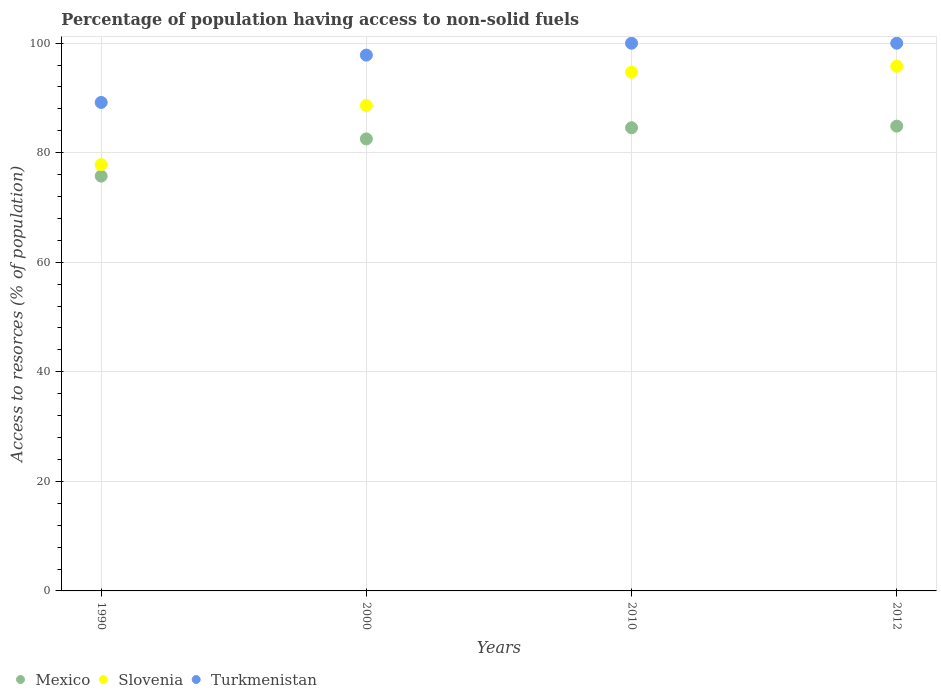How many different coloured dotlines are there?
Provide a short and direct response. 3. Is the number of dotlines equal to the number of legend labels?
Offer a terse response. Yes. What is the percentage of population having access to non-solid fuels in Turkmenistan in 2010?
Ensure brevity in your answer.  99.99. Across all years, what is the maximum percentage of population having access to non-solid fuels in Turkmenistan?
Offer a very short reply. 99.99. Across all years, what is the minimum percentage of population having access to non-solid fuels in Slovenia?
Ensure brevity in your answer.  77.82. In which year was the percentage of population having access to non-solid fuels in Mexico maximum?
Your response must be concise. 2012. In which year was the percentage of population having access to non-solid fuels in Turkmenistan minimum?
Keep it short and to the point. 1990. What is the total percentage of population having access to non-solid fuels in Slovenia in the graph?
Provide a succinct answer. 356.93. What is the difference between the percentage of population having access to non-solid fuels in Slovenia in 2000 and that in 2012?
Your answer should be very brief. -7.17. What is the difference between the percentage of population having access to non-solid fuels in Mexico in 2000 and the percentage of population having access to non-solid fuels in Turkmenistan in 1990?
Make the answer very short. -6.66. What is the average percentage of population having access to non-solid fuels in Slovenia per year?
Your answer should be very brief. 89.23. In the year 2012, what is the difference between the percentage of population having access to non-solid fuels in Turkmenistan and percentage of population having access to non-solid fuels in Mexico?
Your response must be concise. 15.14. In how many years, is the percentage of population having access to non-solid fuels in Turkmenistan greater than 72 %?
Offer a terse response. 4. What is the ratio of the percentage of population having access to non-solid fuels in Slovenia in 2000 to that in 2010?
Your response must be concise. 0.94. Is the difference between the percentage of population having access to non-solid fuels in Turkmenistan in 2000 and 2010 greater than the difference between the percentage of population having access to non-solid fuels in Mexico in 2000 and 2010?
Give a very brief answer. No. What is the difference between the highest and the second highest percentage of population having access to non-solid fuels in Slovenia?
Provide a succinct answer. 1.11. What is the difference between the highest and the lowest percentage of population having access to non-solid fuels in Slovenia?
Provide a succinct answer. 17.97. Is the sum of the percentage of population having access to non-solid fuels in Mexico in 1990 and 2012 greater than the maximum percentage of population having access to non-solid fuels in Slovenia across all years?
Ensure brevity in your answer.  Yes. Is it the case that in every year, the sum of the percentage of population having access to non-solid fuels in Mexico and percentage of population having access to non-solid fuels in Slovenia  is greater than the percentage of population having access to non-solid fuels in Turkmenistan?
Make the answer very short. Yes. Is the percentage of population having access to non-solid fuels in Mexico strictly greater than the percentage of population having access to non-solid fuels in Slovenia over the years?
Ensure brevity in your answer.  No. Is the percentage of population having access to non-solid fuels in Mexico strictly less than the percentage of population having access to non-solid fuels in Slovenia over the years?
Your answer should be very brief. Yes. How many dotlines are there?
Give a very brief answer. 3. What is the difference between two consecutive major ticks on the Y-axis?
Offer a very short reply. 20. Are the values on the major ticks of Y-axis written in scientific E-notation?
Your answer should be very brief. No. Does the graph contain grids?
Provide a succinct answer. Yes. How are the legend labels stacked?
Offer a terse response. Horizontal. What is the title of the graph?
Keep it short and to the point. Percentage of population having access to non-solid fuels. What is the label or title of the Y-axis?
Provide a short and direct response. Access to resorces (% of population). What is the Access to resorces (% of population) in Mexico in 1990?
Give a very brief answer. 75.73. What is the Access to resorces (% of population) in Slovenia in 1990?
Your answer should be very brief. 77.82. What is the Access to resorces (% of population) of Turkmenistan in 1990?
Offer a terse response. 89.18. What is the Access to resorces (% of population) of Mexico in 2000?
Keep it short and to the point. 82.52. What is the Access to resorces (% of population) in Slovenia in 2000?
Give a very brief answer. 88.62. What is the Access to resorces (% of population) in Turkmenistan in 2000?
Your response must be concise. 97.82. What is the Access to resorces (% of population) of Mexico in 2010?
Ensure brevity in your answer.  84.56. What is the Access to resorces (% of population) of Slovenia in 2010?
Offer a very short reply. 94.69. What is the Access to resorces (% of population) of Turkmenistan in 2010?
Ensure brevity in your answer.  99.99. What is the Access to resorces (% of population) of Mexico in 2012?
Offer a terse response. 84.85. What is the Access to resorces (% of population) in Slovenia in 2012?
Give a very brief answer. 95.79. What is the Access to resorces (% of population) in Turkmenistan in 2012?
Your answer should be compact. 99.99. Across all years, what is the maximum Access to resorces (% of population) in Mexico?
Ensure brevity in your answer.  84.85. Across all years, what is the maximum Access to resorces (% of population) in Slovenia?
Make the answer very short. 95.79. Across all years, what is the maximum Access to resorces (% of population) of Turkmenistan?
Give a very brief answer. 99.99. Across all years, what is the minimum Access to resorces (% of population) in Mexico?
Provide a short and direct response. 75.73. Across all years, what is the minimum Access to resorces (% of population) of Slovenia?
Offer a terse response. 77.82. Across all years, what is the minimum Access to resorces (% of population) in Turkmenistan?
Offer a very short reply. 89.18. What is the total Access to resorces (% of population) in Mexico in the graph?
Keep it short and to the point. 327.66. What is the total Access to resorces (% of population) in Slovenia in the graph?
Offer a terse response. 356.93. What is the total Access to resorces (% of population) in Turkmenistan in the graph?
Offer a very short reply. 386.98. What is the difference between the Access to resorces (% of population) of Mexico in 1990 and that in 2000?
Offer a terse response. -6.79. What is the difference between the Access to resorces (% of population) in Slovenia in 1990 and that in 2000?
Offer a very short reply. -10.79. What is the difference between the Access to resorces (% of population) in Turkmenistan in 1990 and that in 2000?
Your answer should be very brief. -8.64. What is the difference between the Access to resorces (% of population) in Mexico in 1990 and that in 2010?
Your answer should be very brief. -8.83. What is the difference between the Access to resorces (% of population) in Slovenia in 1990 and that in 2010?
Offer a terse response. -16.86. What is the difference between the Access to resorces (% of population) of Turkmenistan in 1990 and that in 2010?
Offer a terse response. -10.81. What is the difference between the Access to resorces (% of population) in Mexico in 1990 and that in 2012?
Your answer should be compact. -9.12. What is the difference between the Access to resorces (% of population) of Slovenia in 1990 and that in 2012?
Provide a succinct answer. -17.97. What is the difference between the Access to resorces (% of population) in Turkmenistan in 1990 and that in 2012?
Make the answer very short. -10.81. What is the difference between the Access to resorces (% of population) of Mexico in 2000 and that in 2010?
Your response must be concise. -2.04. What is the difference between the Access to resorces (% of population) of Slovenia in 2000 and that in 2010?
Provide a short and direct response. -6.07. What is the difference between the Access to resorces (% of population) in Turkmenistan in 2000 and that in 2010?
Give a very brief answer. -2.17. What is the difference between the Access to resorces (% of population) in Mexico in 2000 and that in 2012?
Keep it short and to the point. -2.33. What is the difference between the Access to resorces (% of population) of Slovenia in 2000 and that in 2012?
Offer a very short reply. -7.17. What is the difference between the Access to resorces (% of population) of Turkmenistan in 2000 and that in 2012?
Your answer should be compact. -2.17. What is the difference between the Access to resorces (% of population) of Mexico in 2010 and that in 2012?
Keep it short and to the point. -0.29. What is the difference between the Access to resorces (% of population) in Slovenia in 2010 and that in 2012?
Your answer should be compact. -1.11. What is the difference between the Access to resorces (% of population) of Mexico in 1990 and the Access to resorces (% of population) of Slovenia in 2000?
Your answer should be compact. -12.89. What is the difference between the Access to resorces (% of population) in Mexico in 1990 and the Access to resorces (% of population) in Turkmenistan in 2000?
Give a very brief answer. -22.09. What is the difference between the Access to resorces (% of population) in Slovenia in 1990 and the Access to resorces (% of population) in Turkmenistan in 2000?
Your response must be concise. -20. What is the difference between the Access to resorces (% of population) in Mexico in 1990 and the Access to resorces (% of population) in Slovenia in 2010?
Offer a terse response. -18.96. What is the difference between the Access to resorces (% of population) of Mexico in 1990 and the Access to resorces (% of population) of Turkmenistan in 2010?
Offer a very short reply. -24.26. What is the difference between the Access to resorces (% of population) in Slovenia in 1990 and the Access to resorces (% of population) in Turkmenistan in 2010?
Offer a very short reply. -22.16. What is the difference between the Access to resorces (% of population) in Mexico in 1990 and the Access to resorces (% of population) in Slovenia in 2012?
Provide a short and direct response. -20.07. What is the difference between the Access to resorces (% of population) of Mexico in 1990 and the Access to resorces (% of population) of Turkmenistan in 2012?
Your answer should be very brief. -24.26. What is the difference between the Access to resorces (% of population) in Slovenia in 1990 and the Access to resorces (% of population) in Turkmenistan in 2012?
Give a very brief answer. -22.16. What is the difference between the Access to resorces (% of population) in Mexico in 2000 and the Access to resorces (% of population) in Slovenia in 2010?
Give a very brief answer. -12.17. What is the difference between the Access to resorces (% of population) of Mexico in 2000 and the Access to resorces (% of population) of Turkmenistan in 2010?
Provide a succinct answer. -17.47. What is the difference between the Access to resorces (% of population) in Slovenia in 2000 and the Access to resorces (% of population) in Turkmenistan in 2010?
Provide a succinct answer. -11.37. What is the difference between the Access to resorces (% of population) in Mexico in 2000 and the Access to resorces (% of population) in Slovenia in 2012?
Offer a terse response. -13.27. What is the difference between the Access to resorces (% of population) in Mexico in 2000 and the Access to resorces (% of population) in Turkmenistan in 2012?
Offer a very short reply. -17.47. What is the difference between the Access to resorces (% of population) in Slovenia in 2000 and the Access to resorces (% of population) in Turkmenistan in 2012?
Offer a very short reply. -11.37. What is the difference between the Access to resorces (% of population) of Mexico in 2010 and the Access to resorces (% of population) of Slovenia in 2012?
Your answer should be compact. -11.24. What is the difference between the Access to resorces (% of population) in Mexico in 2010 and the Access to resorces (% of population) in Turkmenistan in 2012?
Provide a succinct answer. -15.43. What is the difference between the Access to resorces (% of population) in Slovenia in 2010 and the Access to resorces (% of population) in Turkmenistan in 2012?
Provide a succinct answer. -5.3. What is the average Access to resorces (% of population) of Mexico per year?
Ensure brevity in your answer.  81.92. What is the average Access to resorces (% of population) in Slovenia per year?
Give a very brief answer. 89.23. What is the average Access to resorces (% of population) in Turkmenistan per year?
Your response must be concise. 96.74. In the year 1990, what is the difference between the Access to resorces (% of population) in Mexico and Access to resorces (% of population) in Slovenia?
Make the answer very short. -2.1. In the year 1990, what is the difference between the Access to resorces (% of population) of Mexico and Access to resorces (% of population) of Turkmenistan?
Ensure brevity in your answer.  -13.45. In the year 1990, what is the difference between the Access to resorces (% of population) of Slovenia and Access to resorces (% of population) of Turkmenistan?
Offer a very short reply. -11.35. In the year 2000, what is the difference between the Access to resorces (% of population) in Mexico and Access to resorces (% of population) in Slovenia?
Give a very brief answer. -6.1. In the year 2000, what is the difference between the Access to resorces (% of population) of Mexico and Access to resorces (% of population) of Turkmenistan?
Offer a terse response. -15.3. In the year 2000, what is the difference between the Access to resorces (% of population) of Slovenia and Access to resorces (% of population) of Turkmenistan?
Ensure brevity in your answer.  -9.2. In the year 2010, what is the difference between the Access to resorces (% of population) of Mexico and Access to resorces (% of population) of Slovenia?
Keep it short and to the point. -10.13. In the year 2010, what is the difference between the Access to resorces (% of population) of Mexico and Access to resorces (% of population) of Turkmenistan?
Your answer should be very brief. -15.43. In the year 2010, what is the difference between the Access to resorces (% of population) in Slovenia and Access to resorces (% of population) in Turkmenistan?
Provide a succinct answer. -5.3. In the year 2012, what is the difference between the Access to resorces (% of population) in Mexico and Access to resorces (% of population) in Slovenia?
Keep it short and to the point. -10.94. In the year 2012, what is the difference between the Access to resorces (% of population) in Mexico and Access to resorces (% of population) in Turkmenistan?
Provide a short and direct response. -15.14. In the year 2012, what is the difference between the Access to resorces (% of population) in Slovenia and Access to resorces (% of population) in Turkmenistan?
Give a very brief answer. -4.2. What is the ratio of the Access to resorces (% of population) of Mexico in 1990 to that in 2000?
Your answer should be compact. 0.92. What is the ratio of the Access to resorces (% of population) of Slovenia in 1990 to that in 2000?
Provide a succinct answer. 0.88. What is the ratio of the Access to resorces (% of population) of Turkmenistan in 1990 to that in 2000?
Offer a terse response. 0.91. What is the ratio of the Access to resorces (% of population) in Mexico in 1990 to that in 2010?
Your response must be concise. 0.9. What is the ratio of the Access to resorces (% of population) in Slovenia in 1990 to that in 2010?
Offer a terse response. 0.82. What is the ratio of the Access to resorces (% of population) of Turkmenistan in 1990 to that in 2010?
Provide a succinct answer. 0.89. What is the ratio of the Access to resorces (% of population) of Mexico in 1990 to that in 2012?
Make the answer very short. 0.89. What is the ratio of the Access to resorces (% of population) of Slovenia in 1990 to that in 2012?
Offer a terse response. 0.81. What is the ratio of the Access to resorces (% of population) of Turkmenistan in 1990 to that in 2012?
Your response must be concise. 0.89. What is the ratio of the Access to resorces (% of population) of Mexico in 2000 to that in 2010?
Offer a terse response. 0.98. What is the ratio of the Access to resorces (% of population) of Slovenia in 2000 to that in 2010?
Keep it short and to the point. 0.94. What is the ratio of the Access to resorces (% of population) in Turkmenistan in 2000 to that in 2010?
Provide a succinct answer. 0.98. What is the ratio of the Access to resorces (% of population) of Mexico in 2000 to that in 2012?
Ensure brevity in your answer.  0.97. What is the ratio of the Access to resorces (% of population) in Slovenia in 2000 to that in 2012?
Offer a terse response. 0.93. What is the ratio of the Access to resorces (% of population) in Turkmenistan in 2000 to that in 2012?
Provide a short and direct response. 0.98. What is the difference between the highest and the second highest Access to resorces (% of population) of Mexico?
Your response must be concise. 0.29. What is the difference between the highest and the second highest Access to resorces (% of population) of Slovenia?
Keep it short and to the point. 1.11. What is the difference between the highest and the lowest Access to resorces (% of population) in Mexico?
Keep it short and to the point. 9.12. What is the difference between the highest and the lowest Access to resorces (% of population) of Slovenia?
Your answer should be compact. 17.97. What is the difference between the highest and the lowest Access to resorces (% of population) in Turkmenistan?
Your response must be concise. 10.81. 